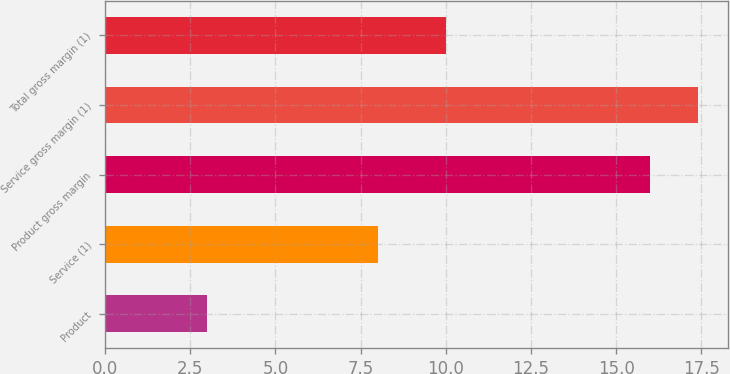Convert chart to OTSL. <chart><loc_0><loc_0><loc_500><loc_500><bar_chart><fcel>Product<fcel>Service (1)<fcel>Product gross margin<fcel>Service gross margin (1)<fcel>Total gross margin (1)<nl><fcel>3<fcel>8<fcel>16<fcel>17.4<fcel>10<nl></chart> 